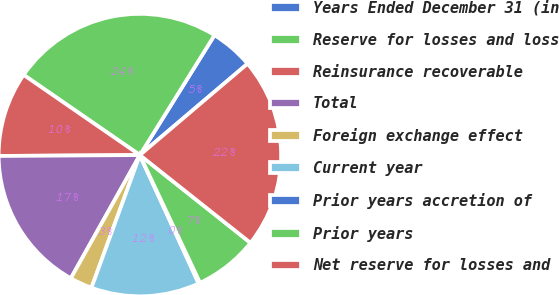Convert chart to OTSL. <chart><loc_0><loc_0><loc_500><loc_500><pie_chart><fcel>Years Ended December 31 (in<fcel>Reserve for losses and loss<fcel>Reinsurance recoverable<fcel>Total<fcel>Foreign exchange effect<fcel>Current year<fcel>Prior years accretion of<fcel>Prior years<fcel>Net reserve for losses and<nl><fcel>4.94%<fcel>24.25%<fcel>9.71%<fcel>16.77%<fcel>2.56%<fcel>12.4%<fcel>0.17%<fcel>7.32%<fcel>21.87%<nl></chart> 